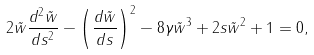<formula> <loc_0><loc_0><loc_500><loc_500>2 \tilde { w } \frac { d ^ { 2 } \tilde { w } } { d s ^ { 2 } } - \left ( \frac { d \tilde { w } } { d s } \right ) ^ { 2 } - 8 \gamma \tilde { w } ^ { 3 } + 2 s \tilde { w } ^ { 2 } + 1 = 0 ,</formula> 